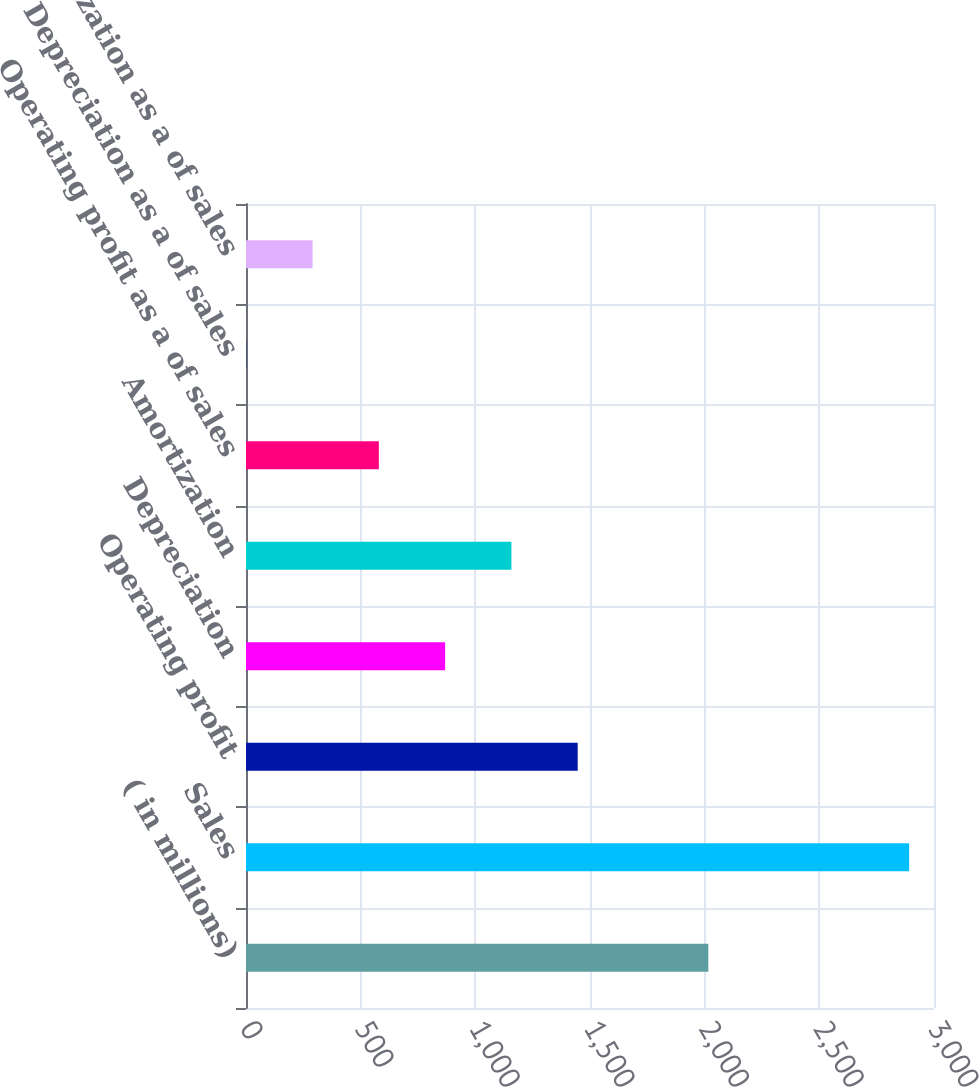<chart> <loc_0><loc_0><loc_500><loc_500><bar_chart><fcel>( in millions)<fcel>Sales<fcel>Operating profit<fcel>Depreciation<fcel>Amortization<fcel>Operating profit as a of sales<fcel>Depreciation as a of sales<fcel>Amortization as a of sales<nl><fcel>2016<fcel>2891.6<fcel>1446.4<fcel>868.32<fcel>1157.36<fcel>579.28<fcel>1.2<fcel>290.24<nl></chart> 